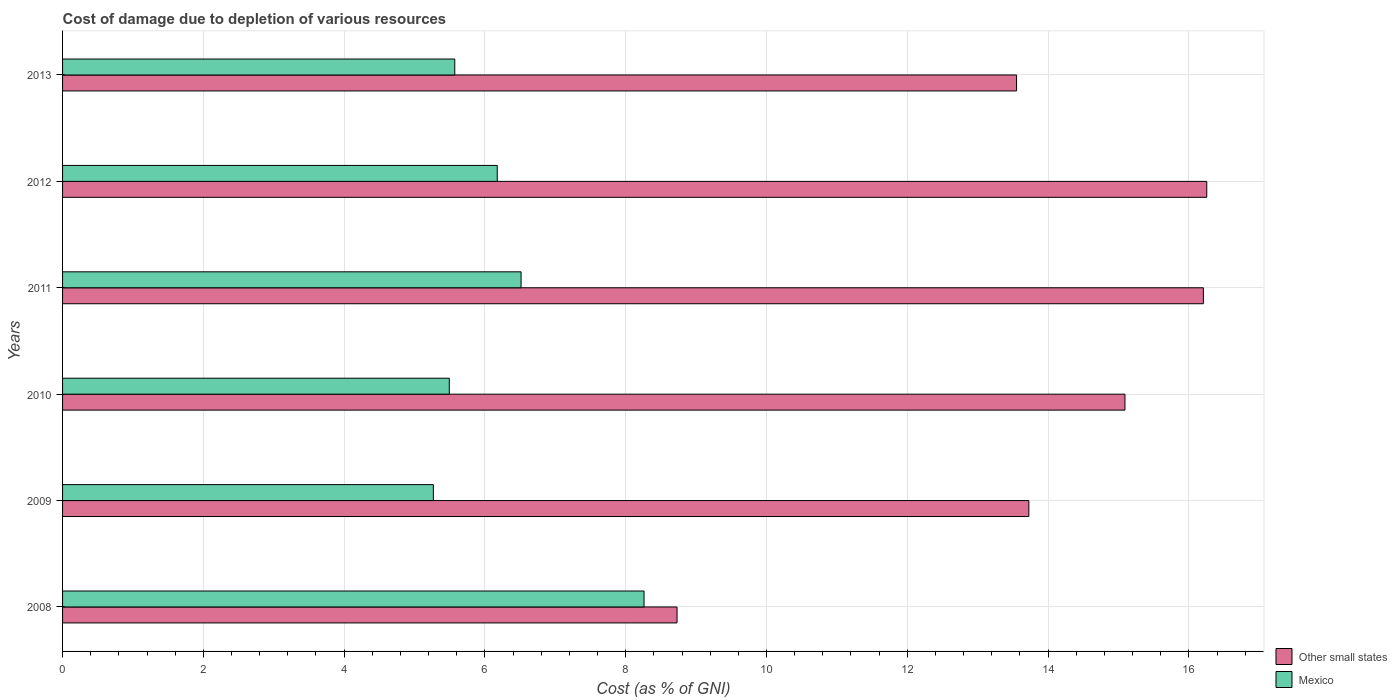How many different coloured bars are there?
Offer a terse response. 2. What is the cost of damage caused due to the depletion of various resources in Mexico in 2010?
Provide a short and direct response. 5.49. Across all years, what is the maximum cost of damage caused due to the depletion of various resources in Mexico?
Offer a very short reply. 8.26. Across all years, what is the minimum cost of damage caused due to the depletion of various resources in Mexico?
Offer a terse response. 5.27. What is the total cost of damage caused due to the depletion of various resources in Mexico in the graph?
Keep it short and to the point. 37.28. What is the difference between the cost of damage caused due to the depletion of various resources in Other small states in 2011 and that in 2012?
Your answer should be compact. -0.05. What is the difference between the cost of damage caused due to the depletion of various resources in Mexico in 2013 and the cost of damage caused due to the depletion of various resources in Other small states in 2012?
Your response must be concise. -10.68. What is the average cost of damage caused due to the depletion of various resources in Other small states per year?
Provide a succinct answer. 13.93. In the year 2010, what is the difference between the cost of damage caused due to the depletion of various resources in Mexico and cost of damage caused due to the depletion of various resources in Other small states?
Your answer should be very brief. -9.6. What is the ratio of the cost of damage caused due to the depletion of various resources in Other small states in 2010 to that in 2013?
Offer a terse response. 1.11. Is the difference between the cost of damage caused due to the depletion of various resources in Mexico in 2012 and 2013 greater than the difference between the cost of damage caused due to the depletion of various resources in Other small states in 2012 and 2013?
Ensure brevity in your answer.  No. What is the difference between the highest and the second highest cost of damage caused due to the depletion of various resources in Other small states?
Provide a short and direct response. 0.05. What is the difference between the highest and the lowest cost of damage caused due to the depletion of various resources in Other small states?
Provide a short and direct response. 7.53. Is the sum of the cost of damage caused due to the depletion of various resources in Other small states in 2009 and 2011 greater than the maximum cost of damage caused due to the depletion of various resources in Mexico across all years?
Offer a terse response. Yes. What does the 2nd bar from the top in 2011 represents?
Offer a very short reply. Other small states. What does the 1st bar from the bottom in 2011 represents?
Give a very brief answer. Other small states. Are the values on the major ticks of X-axis written in scientific E-notation?
Your response must be concise. No. Where does the legend appear in the graph?
Your answer should be compact. Bottom right. How many legend labels are there?
Make the answer very short. 2. What is the title of the graph?
Provide a succinct answer. Cost of damage due to depletion of various resources. Does "Isle of Man" appear as one of the legend labels in the graph?
Provide a succinct answer. No. What is the label or title of the X-axis?
Give a very brief answer. Cost (as % of GNI). What is the Cost (as % of GNI) in Other small states in 2008?
Ensure brevity in your answer.  8.73. What is the Cost (as % of GNI) of Mexico in 2008?
Your answer should be compact. 8.26. What is the Cost (as % of GNI) in Other small states in 2009?
Provide a short and direct response. 13.73. What is the Cost (as % of GNI) in Mexico in 2009?
Keep it short and to the point. 5.27. What is the Cost (as % of GNI) of Other small states in 2010?
Give a very brief answer. 15.09. What is the Cost (as % of GNI) of Mexico in 2010?
Offer a very short reply. 5.49. What is the Cost (as % of GNI) in Other small states in 2011?
Provide a short and direct response. 16.21. What is the Cost (as % of GNI) in Mexico in 2011?
Give a very brief answer. 6.51. What is the Cost (as % of GNI) of Other small states in 2012?
Offer a very short reply. 16.25. What is the Cost (as % of GNI) in Mexico in 2012?
Give a very brief answer. 6.18. What is the Cost (as % of GNI) of Other small states in 2013?
Offer a very short reply. 13.55. What is the Cost (as % of GNI) in Mexico in 2013?
Make the answer very short. 5.57. Across all years, what is the maximum Cost (as % of GNI) in Other small states?
Make the answer very short. 16.25. Across all years, what is the maximum Cost (as % of GNI) in Mexico?
Provide a short and direct response. 8.26. Across all years, what is the minimum Cost (as % of GNI) of Other small states?
Your answer should be very brief. 8.73. Across all years, what is the minimum Cost (as % of GNI) in Mexico?
Keep it short and to the point. 5.27. What is the total Cost (as % of GNI) of Other small states in the graph?
Give a very brief answer. 83.56. What is the total Cost (as % of GNI) in Mexico in the graph?
Provide a succinct answer. 37.28. What is the difference between the Cost (as % of GNI) of Other small states in 2008 and that in 2009?
Offer a terse response. -5. What is the difference between the Cost (as % of GNI) of Mexico in 2008 and that in 2009?
Your answer should be compact. 2.99. What is the difference between the Cost (as % of GNI) in Other small states in 2008 and that in 2010?
Your answer should be compact. -6.36. What is the difference between the Cost (as % of GNI) in Mexico in 2008 and that in 2010?
Ensure brevity in your answer.  2.77. What is the difference between the Cost (as % of GNI) of Other small states in 2008 and that in 2011?
Offer a very short reply. -7.48. What is the difference between the Cost (as % of GNI) of Mexico in 2008 and that in 2011?
Your answer should be very brief. 1.75. What is the difference between the Cost (as % of GNI) in Other small states in 2008 and that in 2012?
Your answer should be very brief. -7.53. What is the difference between the Cost (as % of GNI) in Mexico in 2008 and that in 2012?
Your answer should be compact. 2.09. What is the difference between the Cost (as % of GNI) in Other small states in 2008 and that in 2013?
Your answer should be compact. -4.82. What is the difference between the Cost (as % of GNI) in Mexico in 2008 and that in 2013?
Give a very brief answer. 2.69. What is the difference between the Cost (as % of GNI) of Other small states in 2009 and that in 2010?
Provide a succinct answer. -1.37. What is the difference between the Cost (as % of GNI) of Mexico in 2009 and that in 2010?
Your answer should be very brief. -0.23. What is the difference between the Cost (as % of GNI) of Other small states in 2009 and that in 2011?
Offer a terse response. -2.48. What is the difference between the Cost (as % of GNI) of Mexico in 2009 and that in 2011?
Ensure brevity in your answer.  -1.25. What is the difference between the Cost (as % of GNI) in Other small states in 2009 and that in 2012?
Your answer should be very brief. -2.53. What is the difference between the Cost (as % of GNI) in Mexico in 2009 and that in 2012?
Your answer should be compact. -0.91. What is the difference between the Cost (as % of GNI) in Other small states in 2009 and that in 2013?
Offer a terse response. 0.17. What is the difference between the Cost (as % of GNI) in Mexico in 2009 and that in 2013?
Your answer should be compact. -0.3. What is the difference between the Cost (as % of GNI) of Other small states in 2010 and that in 2011?
Make the answer very short. -1.11. What is the difference between the Cost (as % of GNI) in Mexico in 2010 and that in 2011?
Offer a very short reply. -1.02. What is the difference between the Cost (as % of GNI) in Other small states in 2010 and that in 2012?
Make the answer very short. -1.16. What is the difference between the Cost (as % of GNI) in Mexico in 2010 and that in 2012?
Offer a terse response. -0.68. What is the difference between the Cost (as % of GNI) in Other small states in 2010 and that in 2013?
Your answer should be very brief. 1.54. What is the difference between the Cost (as % of GNI) of Mexico in 2010 and that in 2013?
Your response must be concise. -0.08. What is the difference between the Cost (as % of GNI) of Other small states in 2011 and that in 2012?
Keep it short and to the point. -0.05. What is the difference between the Cost (as % of GNI) in Mexico in 2011 and that in 2012?
Provide a succinct answer. 0.34. What is the difference between the Cost (as % of GNI) in Other small states in 2011 and that in 2013?
Make the answer very short. 2.65. What is the difference between the Cost (as % of GNI) in Mexico in 2011 and that in 2013?
Keep it short and to the point. 0.94. What is the difference between the Cost (as % of GNI) of Other small states in 2012 and that in 2013?
Provide a succinct answer. 2.7. What is the difference between the Cost (as % of GNI) in Mexico in 2012 and that in 2013?
Your answer should be compact. 0.6. What is the difference between the Cost (as % of GNI) of Other small states in 2008 and the Cost (as % of GNI) of Mexico in 2009?
Ensure brevity in your answer.  3.46. What is the difference between the Cost (as % of GNI) of Other small states in 2008 and the Cost (as % of GNI) of Mexico in 2010?
Offer a very short reply. 3.24. What is the difference between the Cost (as % of GNI) of Other small states in 2008 and the Cost (as % of GNI) of Mexico in 2011?
Provide a succinct answer. 2.22. What is the difference between the Cost (as % of GNI) of Other small states in 2008 and the Cost (as % of GNI) of Mexico in 2012?
Provide a succinct answer. 2.55. What is the difference between the Cost (as % of GNI) of Other small states in 2008 and the Cost (as % of GNI) of Mexico in 2013?
Provide a short and direct response. 3.16. What is the difference between the Cost (as % of GNI) of Other small states in 2009 and the Cost (as % of GNI) of Mexico in 2010?
Provide a succinct answer. 8.23. What is the difference between the Cost (as % of GNI) in Other small states in 2009 and the Cost (as % of GNI) in Mexico in 2011?
Your answer should be very brief. 7.21. What is the difference between the Cost (as % of GNI) in Other small states in 2009 and the Cost (as % of GNI) in Mexico in 2012?
Offer a very short reply. 7.55. What is the difference between the Cost (as % of GNI) in Other small states in 2009 and the Cost (as % of GNI) in Mexico in 2013?
Your answer should be compact. 8.16. What is the difference between the Cost (as % of GNI) of Other small states in 2010 and the Cost (as % of GNI) of Mexico in 2011?
Provide a succinct answer. 8.58. What is the difference between the Cost (as % of GNI) of Other small states in 2010 and the Cost (as % of GNI) of Mexico in 2012?
Your answer should be very brief. 8.92. What is the difference between the Cost (as % of GNI) of Other small states in 2010 and the Cost (as % of GNI) of Mexico in 2013?
Provide a short and direct response. 9.52. What is the difference between the Cost (as % of GNI) in Other small states in 2011 and the Cost (as % of GNI) in Mexico in 2012?
Your answer should be compact. 10.03. What is the difference between the Cost (as % of GNI) in Other small states in 2011 and the Cost (as % of GNI) in Mexico in 2013?
Your answer should be very brief. 10.63. What is the difference between the Cost (as % of GNI) in Other small states in 2012 and the Cost (as % of GNI) in Mexico in 2013?
Give a very brief answer. 10.68. What is the average Cost (as % of GNI) in Other small states per year?
Provide a short and direct response. 13.93. What is the average Cost (as % of GNI) of Mexico per year?
Keep it short and to the point. 6.21. In the year 2008, what is the difference between the Cost (as % of GNI) in Other small states and Cost (as % of GNI) in Mexico?
Offer a very short reply. 0.47. In the year 2009, what is the difference between the Cost (as % of GNI) in Other small states and Cost (as % of GNI) in Mexico?
Your response must be concise. 8.46. In the year 2010, what is the difference between the Cost (as % of GNI) in Other small states and Cost (as % of GNI) in Mexico?
Provide a short and direct response. 9.6. In the year 2011, what is the difference between the Cost (as % of GNI) in Other small states and Cost (as % of GNI) in Mexico?
Ensure brevity in your answer.  9.69. In the year 2012, what is the difference between the Cost (as % of GNI) of Other small states and Cost (as % of GNI) of Mexico?
Your answer should be compact. 10.08. In the year 2013, what is the difference between the Cost (as % of GNI) of Other small states and Cost (as % of GNI) of Mexico?
Your answer should be very brief. 7.98. What is the ratio of the Cost (as % of GNI) of Other small states in 2008 to that in 2009?
Your answer should be compact. 0.64. What is the ratio of the Cost (as % of GNI) in Mexico in 2008 to that in 2009?
Give a very brief answer. 1.57. What is the ratio of the Cost (as % of GNI) in Other small states in 2008 to that in 2010?
Provide a short and direct response. 0.58. What is the ratio of the Cost (as % of GNI) in Mexico in 2008 to that in 2010?
Ensure brevity in your answer.  1.5. What is the ratio of the Cost (as % of GNI) of Other small states in 2008 to that in 2011?
Your answer should be compact. 0.54. What is the ratio of the Cost (as % of GNI) of Mexico in 2008 to that in 2011?
Your answer should be very brief. 1.27. What is the ratio of the Cost (as % of GNI) of Other small states in 2008 to that in 2012?
Offer a terse response. 0.54. What is the ratio of the Cost (as % of GNI) in Mexico in 2008 to that in 2012?
Your answer should be compact. 1.34. What is the ratio of the Cost (as % of GNI) in Other small states in 2008 to that in 2013?
Your response must be concise. 0.64. What is the ratio of the Cost (as % of GNI) of Mexico in 2008 to that in 2013?
Keep it short and to the point. 1.48. What is the ratio of the Cost (as % of GNI) in Other small states in 2009 to that in 2010?
Make the answer very short. 0.91. What is the ratio of the Cost (as % of GNI) of Mexico in 2009 to that in 2010?
Provide a succinct answer. 0.96. What is the ratio of the Cost (as % of GNI) in Other small states in 2009 to that in 2011?
Your response must be concise. 0.85. What is the ratio of the Cost (as % of GNI) of Mexico in 2009 to that in 2011?
Your answer should be very brief. 0.81. What is the ratio of the Cost (as % of GNI) in Other small states in 2009 to that in 2012?
Your answer should be compact. 0.84. What is the ratio of the Cost (as % of GNI) of Mexico in 2009 to that in 2012?
Your answer should be very brief. 0.85. What is the ratio of the Cost (as % of GNI) of Other small states in 2009 to that in 2013?
Provide a short and direct response. 1.01. What is the ratio of the Cost (as % of GNI) of Mexico in 2009 to that in 2013?
Your answer should be very brief. 0.95. What is the ratio of the Cost (as % of GNI) of Other small states in 2010 to that in 2011?
Your answer should be very brief. 0.93. What is the ratio of the Cost (as % of GNI) of Mexico in 2010 to that in 2011?
Make the answer very short. 0.84. What is the ratio of the Cost (as % of GNI) of Other small states in 2010 to that in 2012?
Provide a succinct answer. 0.93. What is the ratio of the Cost (as % of GNI) of Mexico in 2010 to that in 2012?
Make the answer very short. 0.89. What is the ratio of the Cost (as % of GNI) in Other small states in 2010 to that in 2013?
Provide a short and direct response. 1.11. What is the ratio of the Cost (as % of GNI) of Other small states in 2011 to that in 2012?
Provide a short and direct response. 1. What is the ratio of the Cost (as % of GNI) of Mexico in 2011 to that in 2012?
Make the answer very short. 1.05. What is the ratio of the Cost (as % of GNI) of Other small states in 2011 to that in 2013?
Provide a succinct answer. 1.2. What is the ratio of the Cost (as % of GNI) of Mexico in 2011 to that in 2013?
Your response must be concise. 1.17. What is the ratio of the Cost (as % of GNI) of Other small states in 2012 to that in 2013?
Provide a short and direct response. 1.2. What is the ratio of the Cost (as % of GNI) of Mexico in 2012 to that in 2013?
Your response must be concise. 1.11. What is the difference between the highest and the second highest Cost (as % of GNI) of Other small states?
Offer a very short reply. 0.05. What is the difference between the highest and the second highest Cost (as % of GNI) of Mexico?
Your answer should be very brief. 1.75. What is the difference between the highest and the lowest Cost (as % of GNI) of Other small states?
Your response must be concise. 7.53. What is the difference between the highest and the lowest Cost (as % of GNI) in Mexico?
Offer a very short reply. 2.99. 